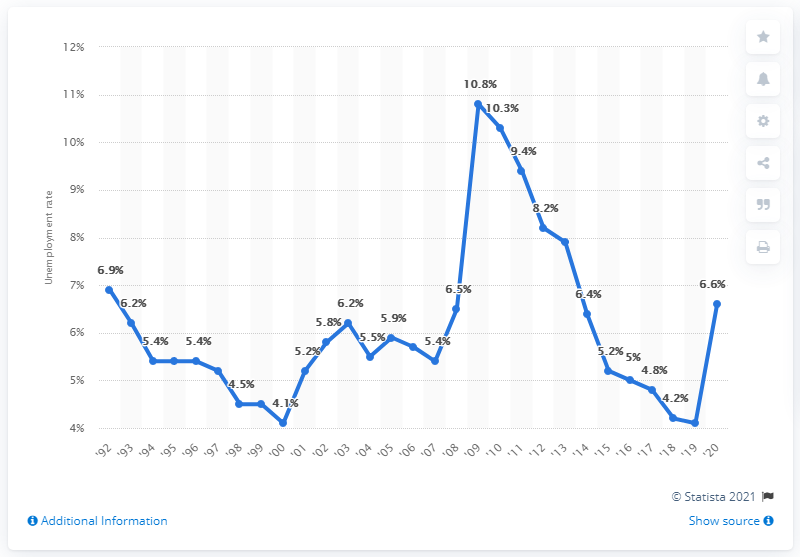Give some essential details in this illustration. In 2020, the unemployment rate in Kentucky was 6.6%. 